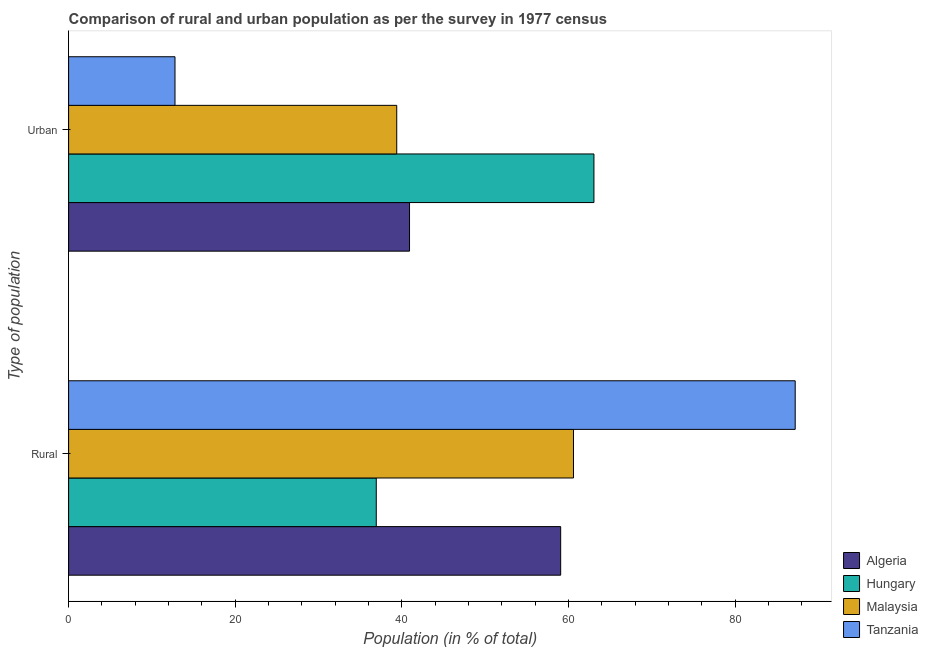How many different coloured bars are there?
Give a very brief answer. 4. How many bars are there on the 1st tick from the top?
Provide a succinct answer. 4. What is the label of the 1st group of bars from the top?
Provide a short and direct response. Urban. What is the rural population in Algeria?
Your answer should be compact. 59.07. Across all countries, what is the maximum rural population?
Your answer should be very brief. 87.23. Across all countries, what is the minimum urban population?
Give a very brief answer. 12.77. In which country was the urban population maximum?
Your answer should be compact. Hungary. In which country was the urban population minimum?
Offer a terse response. Tanzania. What is the total rural population in the graph?
Make the answer very short. 243.84. What is the difference between the urban population in Algeria and that in Hungary?
Offer a very short reply. -22.14. What is the difference between the rural population in Malaysia and the urban population in Algeria?
Provide a succinct answer. 19.68. What is the average urban population per country?
Ensure brevity in your answer.  39.04. What is the difference between the rural population and urban population in Algeria?
Offer a very short reply. 18.14. In how many countries, is the urban population greater than 76 %?
Ensure brevity in your answer.  0. What is the ratio of the rural population in Hungary to that in Tanzania?
Your answer should be very brief. 0.42. What does the 3rd bar from the top in Urban represents?
Give a very brief answer. Hungary. What does the 2nd bar from the bottom in Rural represents?
Keep it short and to the point. Hungary. Are all the bars in the graph horizontal?
Offer a very short reply. Yes. What is the difference between two consecutive major ticks on the X-axis?
Offer a terse response. 20. Are the values on the major ticks of X-axis written in scientific E-notation?
Provide a succinct answer. No. Does the graph contain grids?
Your response must be concise. No. Where does the legend appear in the graph?
Ensure brevity in your answer.  Bottom right. What is the title of the graph?
Your answer should be compact. Comparison of rural and urban population as per the survey in 1977 census. Does "Comoros" appear as one of the legend labels in the graph?
Your answer should be very brief. No. What is the label or title of the X-axis?
Offer a very short reply. Population (in % of total). What is the label or title of the Y-axis?
Your answer should be very brief. Type of population. What is the Population (in % of total) in Algeria in Rural?
Offer a terse response. 59.07. What is the Population (in % of total) in Hungary in Rural?
Make the answer very short. 36.93. What is the Population (in % of total) of Malaysia in Rural?
Ensure brevity in your answer.  60.61. What is the Population (in % of total) of Tanzania in Rural?
Provide a succinct answer. 87.23. What is the Population (in % of total) in Algeria in Urban?
Offer a very short reply. 40.93. What is the Population (in % of total) in Hungary in Urban?
Provide a succinct answer. 63.07. What is the Population (in % of total) in Malaysia in Urban?
Make the answer very short. 39.39. What is the Population (in % of total) of Tanzania in Urban?
Your response must be concise. 12.77. Across all Type of population, what is the maximum Population (in % of total) in Algeria?
Provide a short and direct response. 59.07. Across all Type of population, what is the maximum Population (in % of total) of Hungary?
Your response must be concise. 63.07. Across all Type of population, what is the maximum Population (in % of total) of Malaysia?
Ensure brevity in your answer.  60.61. Across all Type of population, what is the maximum Population (in % of total) in Tanzania?
Your response must be concise. 87.23. Across all Type of population, what is the minimum Population (in % of total) of Algeria?
Offer a terse response. 40.93. Across all Type of population, what is the minimum Population (in % of total) in Hungary?
Your answer should be compact. 36.93. Across all Type of population, what is the minimum Population (in % of total) in Malaysia?
Provide a short and direct response. 39.39. Across all Type of population, what is the minimum Population (in % of total) in Tanzania?
Your answer should be compact. 12.77. What is the total Population (in % of total) of Hungary in the graph?
Your answer should be very brief. 100. What is the total Population (in % of total) of Malaysia in the graph?
Your response must be concise. 100. What is the difference between the Population (in % of total) in Algeria in Rural and that in Urban?
Your answer should be very brief. 18.14. What is the difference between the Population (in % of total) in Hungary in Rural and that in Urban?
Your answer should be very brief. -26.13. What is the difference between the Population (in % of total) of Malaysia in Rural and that in Urban?
Make the answer very short. 21.22. What is the difference between the Population (in % of total) in Tanzania in Rural and that in Urban?
Offer a terse response. 74.45. What is the difference between the Population (in % of total) in Algeria in Rural and the Population (in % of total) in Hungary in Urban?
Your response must be concise. -3.99. What is the difference between the Population (in % of total) in Algeria in Rural and the Population (in % of total) in Malaysia in Urban?
Give a very brief answer. 19.68. What is the difference between the Population (in % of total) of Algeria in Rural and the Population (in % of total) of Tanzania in Urban?
Keep it short and to the point. 46.3. What is the difference between the Population (in % of total) in Hungary in Rural and the Population (in % of total) in Malaysia in Urban?
Ensure brevity in your answer.  -2.46. What is the difference between the Population (in % of total) of Hungary in Rural and the Population (in % of total) of Tanzania in Urban?
Keep it short and to the point. 24.16. What is the difference between the Population (in % of total) of Malaysia in Rural and the Population (in % of total) of Tanzania in Urban?
Ensure brevity in your answer.  47.84. What is the average Population (in % of total) in Algeria per Type of population?
Ensure brevity in your answer.  50. What is the average Population (in % of total) of Malaysia per Type of population?
Your response must be concise. 50. What is the average Population (in % of total) in Tanzania per Type of population?
Give a very brief answer. 50. What is the difference between the Population (in % of total) of Algeria and Population (in % of total) of Hungary in Rural?
Offer a terse response. 22.14. What is the difference between the Population (in % of total) of Algeria and Population (in % of total) of Malaysia in Rural?
Provide a short and direct response. -1.54. What is the difference between the Population (in % of total) of Algeria and Population (in % of total) of Tanzania in Rural?
Provide a short and direct response. -28.16. What is the difference between the Population (in % of total) of Hungary and Population (in % of total) of Malaysia in Rural?
Ensure brevity in your answer.  -23.68. What is the difference between the Population (in % of total) in Hungary and Population (in % of total) in Tanzania in Rural?
Provide a succinct answer. -50.29. What is the difference between the Population (in % of total) in Malaysia and Population (in % of total) in Tanzania in Rural?
Offer a very short reply. -26.62. What is the difference between the Population (in % of total) in Algeria and Population (in % of total) in Hungary in Urban?
Keep it short and to the point. -22.14. What is the difference between the Population (in % of total) in Algeria and Population (in % of total) in Malaysia in Urban?
Make the answer very short. 1.54. What is the difference between the Population (in % of total) of Algeria and Population (in % of total) of Tanzania in Urban?
Your response must be concise. 28.16. What is the difference between the Population (in % of total) of Hungary and Population (in % of total) of Malaysia in Urban?
Offer a terse response. 23.68. What is the difference between the Population (in % of total) of Hungary and Population (in % of total) of Tanzania in Urban?
Provide a short and direct response. 50.29. What is the difference between the Population (in % of total) in Malaysia and Population (in % of total) in Tanzania in Urban?
Offer a very short reply. 26.62. What is the ratio of the Population (in % of total) in Algeria in Rural to that in Urban?
Provide a short and direct response. 1.44. What is the ratio of the Population (in % of total) of Hungary in Rural to that in Urban?
Offer a terse response. 0.59. What is the ratio of the Population (in % of total) of Malaysia in Rural to that in Urban?
Your response must be concise. 1.54. What is the ratio of the Population (in % of total) in Tanzania in Rural to that in Urban?
Offer a very short reply. 6.83. What is the difference between the highest and the second highest Population (in % of total) of Algeria?
Provide a short and direct response. 18.14. What is the difference between the highest and the second highest Population (in % of total) in Hungary?
Keep it short and to the point. 26.13. What is the difference between the highest and the second highest Population (in % of total) of Malaysia?
Make the answer very short. 21.22. What is the difference between the highest and the second highest Population (in % of total) in Tanzania?
Provide a short and direct response. 74.45. What is the difference between the highest and the lowest Population (in % of total) in Algeria?
Your answer should be compact. 18.14. What is the difference between the highest and the lowest Population (in % of total) in Hungary?
Your response must be concise. 26.13. What is the difference between the highest and the lowest Population (in % of total) in Malaysia?
Your response must be concise. 21.22. What is the difference between the highest and the lowest Population (in % of total) in Tanzania?
Your answer should be very brief. 74.45. 